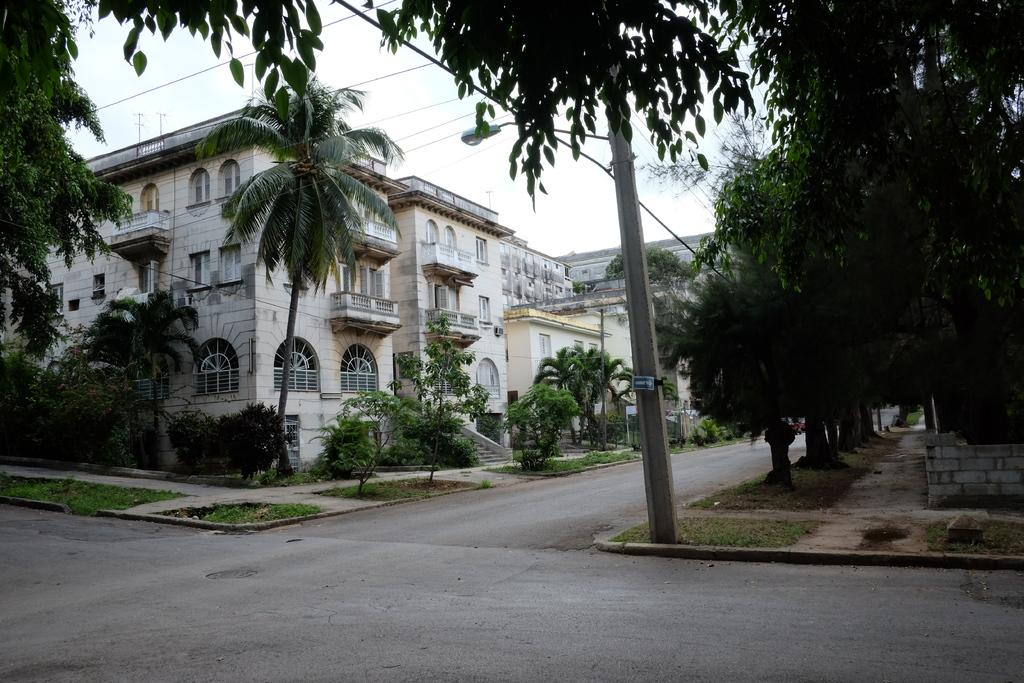What type of structures are visible in the image? There are buildings with windows in the image. What type of vegetation can be seen in the image? There are trees and small bushes in the image. What type of utility pole is present in the image? There is a current pole in the image. What type of lighting fixture is present in the image? There is a street light in the image. What type of pathway is visible in the image? There is a road in the image. What type of breakfast is being served in the image? There is no breakfast present in the image; it features buildings, trees, bushes, a current pole, a street light, and a road. What type of feast is being held in the image? There is no feast present in the image; it features buildings, trees, bushes, a current pole, a street light, and a road. 